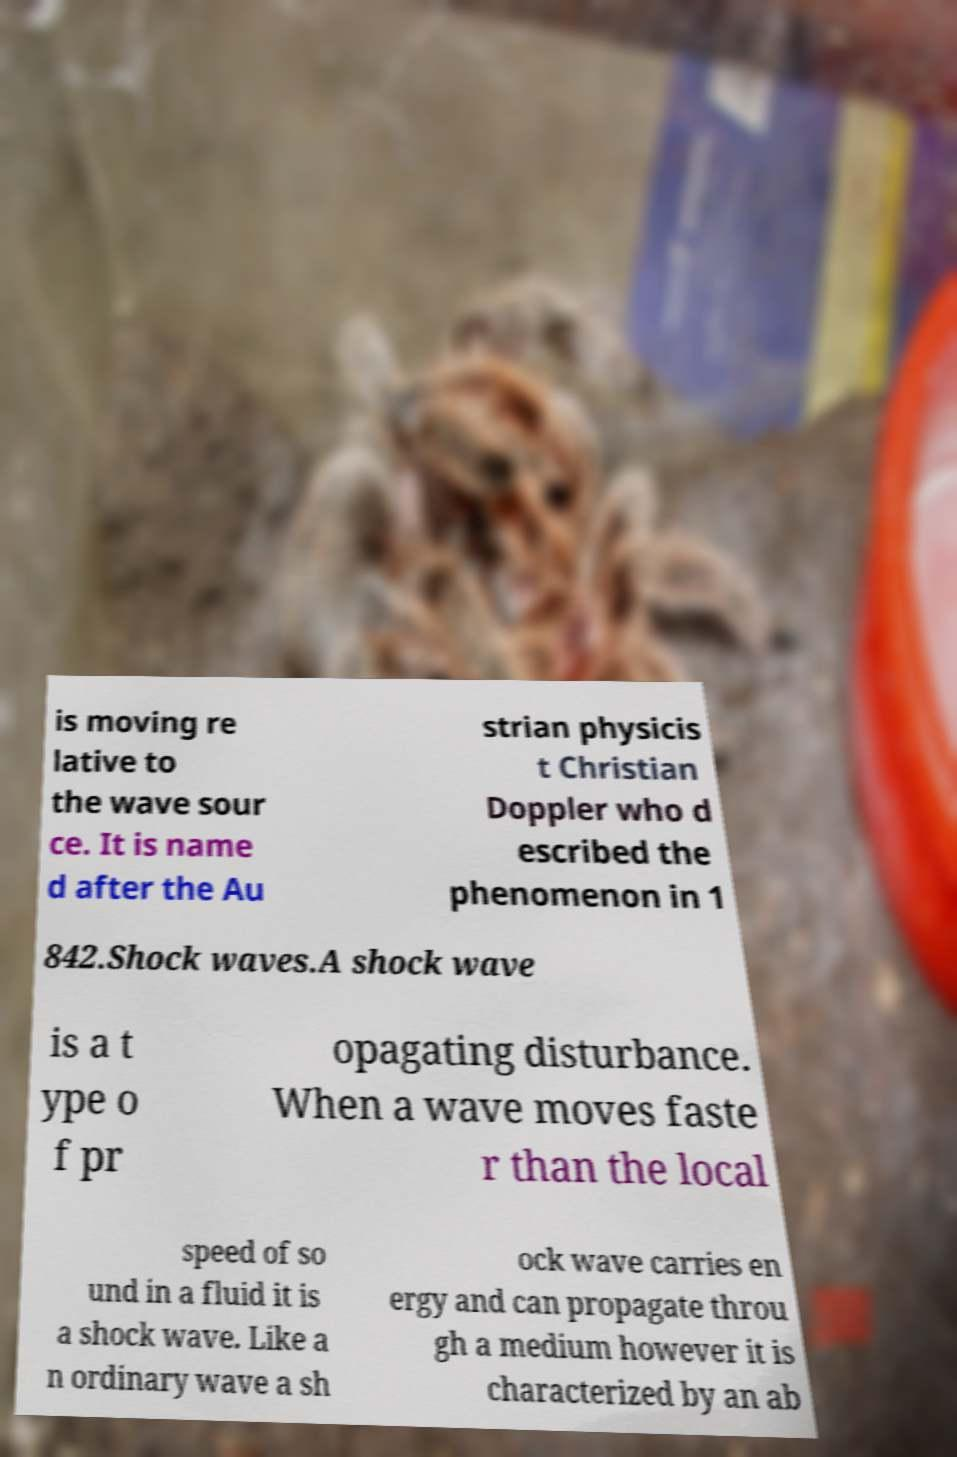Can you accurately transcribe the text from the provided image for me? is moving re lative to the wave sour ce. It is name d after the Au strian physicis t Christian Doppler who d escribed the phenomenon in 1 842.Shock waves.A shock wave is a t ype o f pr opagating disturbance. When a wave moves faste r than the local speed of so und in a fluid it is a shock wave. Like a n ordinary wave a sh ock wave carries en ergy and can propagate throu gh a medium however it is characterized by an ab 